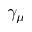<formula> <loc_0><loc_0><loc_500><loc_500>\gamma _ { \mu }</formula> 